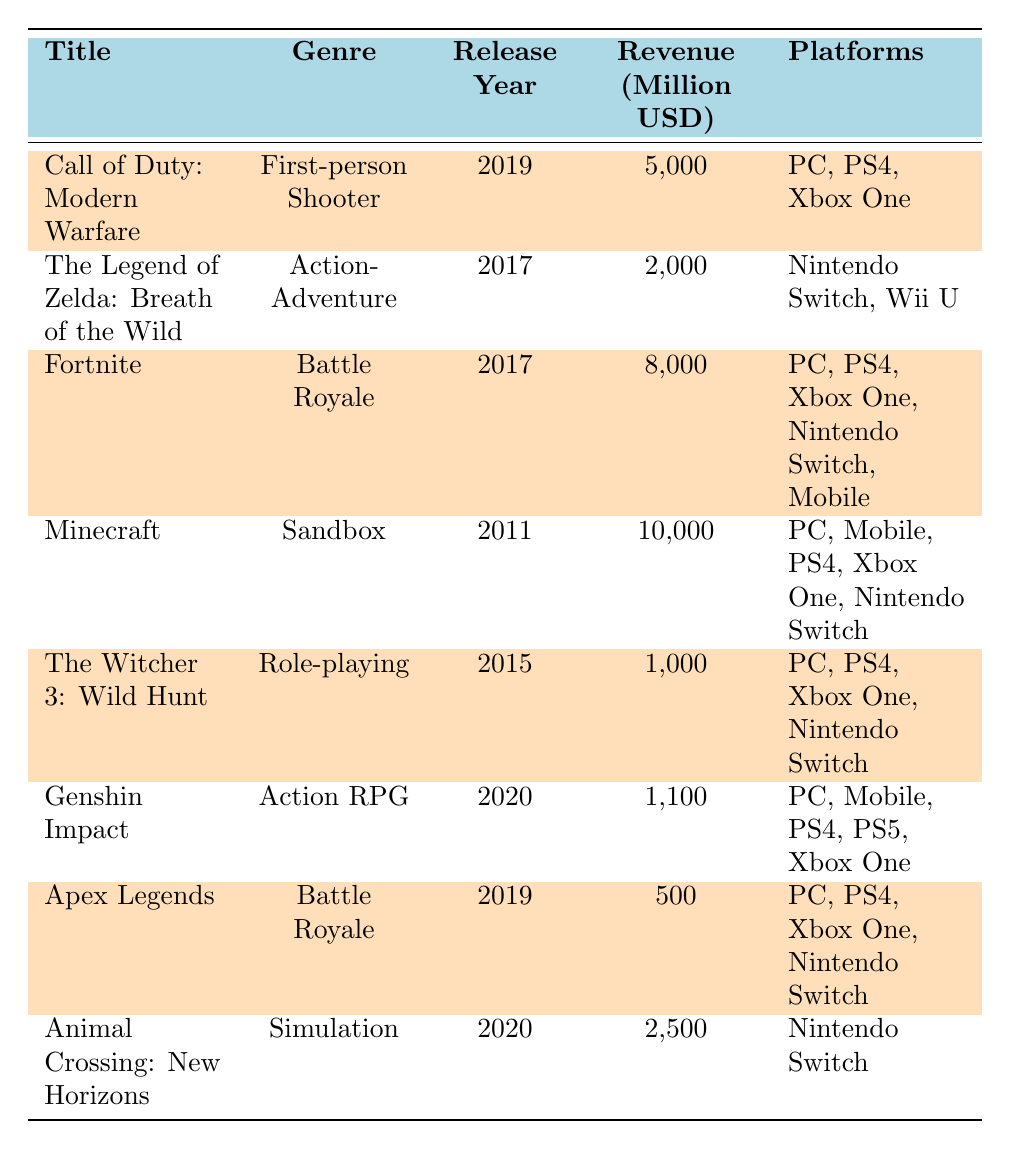What is the total revenue generated by all the video games listed? To find the total revenue, we sum the revenue of each game: 5000 + 2000 + 8000 + 10000 + 1000 + 1100 + 500 + 2500 = 50000 million USD.
Answer: 50000 million USD Which game has the highest revenue? By looking through the revenue column, Minecraft has the highest revenue at 10000 million USD.
Answer: Minecraft Did all the games release after 2015 generate more than 1000 million USD in revenue? The games that released after 2015 are Call of Duty: Modern Warfare (5000 million USD), Fortnite (8000 million USD), Genshin Impact (1100 million USD), and Animal Crossing: New Horizons (2500 million USD). All these games generated more than 1000 million USD.
Answer: Yes How many different platforms does Fortnite support? Checking the platforms column for Fortnite, it supports PC, PS4, Xbox One, Nintendo Switch, and Mobile, which totals to five different platforms.
Answer: 5 What is the revenue difference between Minecraft and Genshin Impact? Minecraft generated 10000 million USD and Genshin Impact generated 1100 million USD. The revenue difference is calculated as 10000 - 1100 = 8900 million USD.
Answer: 8900 million USD Is the genre "Action RPG" represented in the table? Yes, Genshin Impact is categorized under the genre "Action RPG."
Answer: Yes What is the average revenue of first-person shooters listed in the table? The only first-person shooter listed is Call of Duty: Modern Warfare, which has a revenue of 5000 million USD. The average thus remains 5000 since it's the only game in that category.
Answer: 5000 million USD Which genre has the lowest total revenue? The revenue for the genres is: First-person Shooter (5000), Action-Adventure (2000), Battle Royale (8000), Sandbox (10000), Role-playing (1000), Action RPG (1100), and Simulation (2500). The lowest revenue is from Role-playing at 1000 million USD.
Answer: Role-playing If you combine the revenue from both Battle Royale games, what would that amount to? The revenue from Fortnite is 8000 million USD and from Apex Legends is 500 million USD. Combined, they total 8000 + 500 = 8500 million USD.
Answer: 8500 million USD 